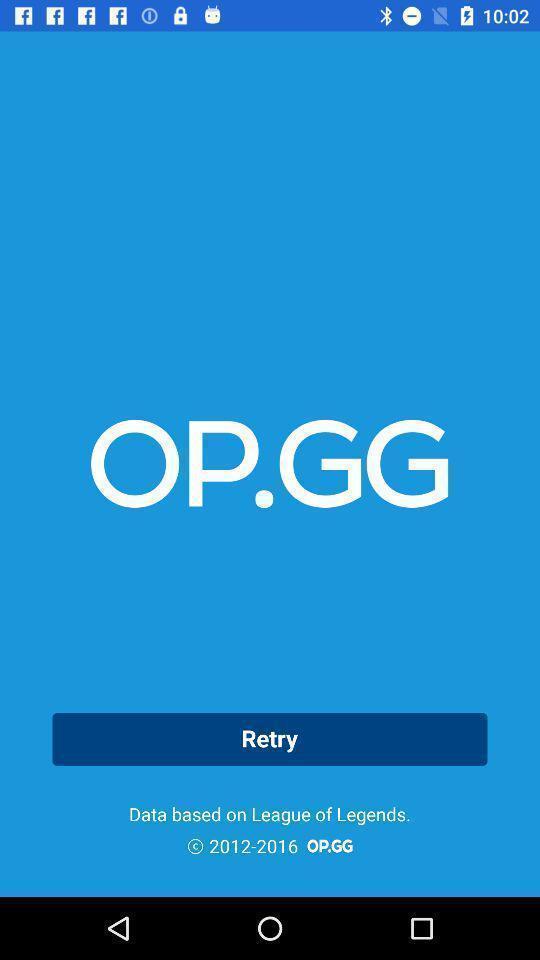What can you discern from this picture? Page showing an option of retry. 